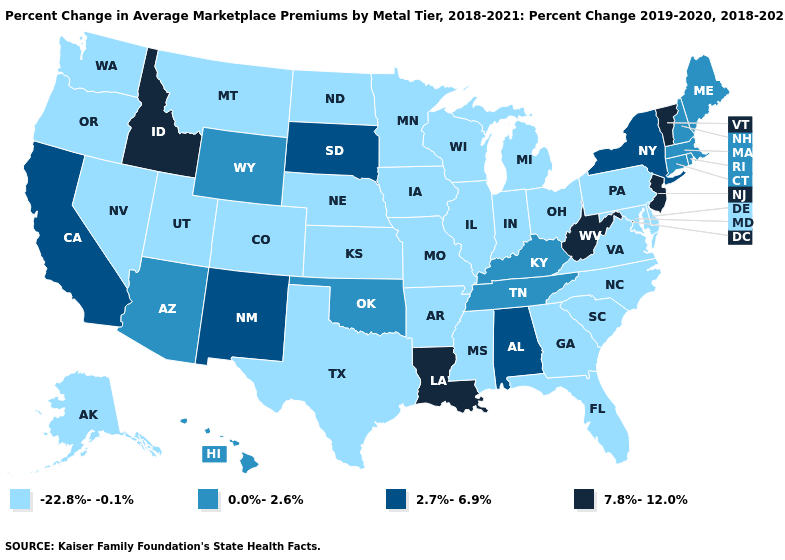What is the value of Alabama?
Answer briefly. 2.7%-6.9%. Among the states that border New Hampshire , does Vermont have the lowest value?
Answer briefly. No. Does North Carolina have the highest value in the South?
Short answer required. No. Which states have the lowest value in the West?
Keep it brief. Alaska, Colorado, Montana, Nevada, Oregon, Utah, Washington. Does the map have missing data?
Write a very short answer. No. Does Oklahoma have a higher value than New Jersey?
Concise answer only. No. Does the first symbol in the legend represent the smallest category?
Concise answer only. Yes. Among the states that border New Mexico , does Texas have the lowest value?
Quick response, please. Yes. Which states have the highest value in the USA?
Be succinct. Idaho, Louisiana, New Jersey, Vermont, West Virginia. Name the states that have a value in the range -22.8%--0.1%?
Quick response, please. Alaska, Arkansas, Colorado, Delaware, Florida, Georgia, Illinois, Indiana, Iowa, Kansas, Maryland, Michigan, Minnesota, Mississippi, Missouri, Montana, Nebraska, Nevada, North Carolina, North Dakota, Ohio, Oregon, Pennsylvania, South Carolina, Texas, Utah, Virginia, Washington, Wisconsin. Does the map have missing data?
Answer briefly. No. Name the states that have a value in the range -22.8%--0.1%?
Give a very brief answer. Alaska, Arkansas, Colorado, Delaware, Florida, Georgia, Illinois, Indiana, Iowa, Kansas, Maryland, Michigan, Minnesota, Mississippi, Missouri, Montana, Nebraska, Nevada, North Carolina, North Dakota, Ohio, Oregon, Pennsylvania, South Carolina, Texas, Utah, Virginia, Washington, Wisconsin. Which states have the highest value in the USA?
Write a very short answer. Idaho, Louisiana, New Jersey, Vermont, West Virginia. Is the legend a continuous bar?
Write a very short answer. No. What is the value of Kentucky?
Answer briefly. 0.0%-2.6%. 